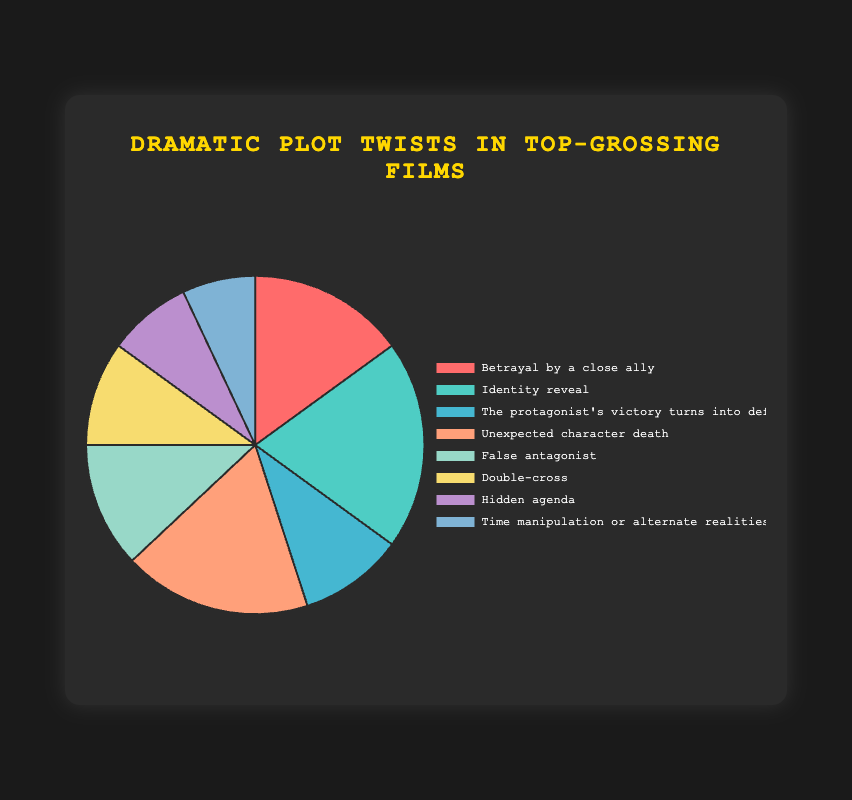Which type of dramatic plot twist is used most frequently in top-grossing films? The pie chart shows that "Identity reveal" has the largest slice, indicating it is the most frequently used plot twist.
Answer: Identity reveal What percentage of plot twists involve character betrayals (including both "Betrayal by a close ally" and "Double-cross")? The chart shows "Betrayal by a close ally" at 15% and "Double-cross" at 10%. Adding them, 15% + 10% = 25%.
Answer: 25% How does the frequency of the "Unexpected character death" plot twist compare to the "False antagonist" twist? "Unexpected character death" is 18% and "False antagonist" is 12%. Comparing the two, 18% is greater than 12%.
Answer: 18% is greater than 12% Which plot twist has the smallest representation in the pie chart? The type with the smallest slice is "Time manipulation or alternate realities" with 7%.
Answer: Time manipulation or alternate realities How does the sum of the percentages for "Hidden agenda" and "Time manipulation or alternate realities" compare to "Identity reveal"? "Hidden agenda" is 8%, "Time manipulation or alternate realities" is 7%. Adding them, 8% + 7% = 15%, while "Identity reveal" is 20%. Therefore, 15% < 20%.
Answer: 15% is less than 20% What is the combined percentage of plot twists involving identity-related themes ("Identity reveal" and "False antagonist")? "Identity reveal" is 20% and "False antagonist" is 12%. Adding them, 20% + 12% = 32%.
Answer: 32% Which plot twists occupy the top three largest portions of the pie chart? The pie chart's largest portions are "Identity reveal" at 20%, "Unexpected character death" at 18%, and "Betrayal by a close ally" at 15%.
Answer: Identity reveal, Unexpected character death, Betrayal by a close ally If you were to combine the categories "The protagonist's victory turns into defeat" and "Double-cross," what would their total percentage be, and how would it compare to "Unexpected character death"? "The protagonist's victory turns into defeat" is 10%, and "Double-cross" is 10%. Adding them, 10% + 10% = 20%, which is more than "Unexpected character death" at 18%.
Answer: 20% is more than 18% What visual attribute helps you identify the type of dramatic plot twist associated with the highest frequency? The largest slice in the pie chart is visually distinctive due to its size and the corresponding legend label, which indicates "Identity reveal".
Answer: Largest slice, Identity reveal 